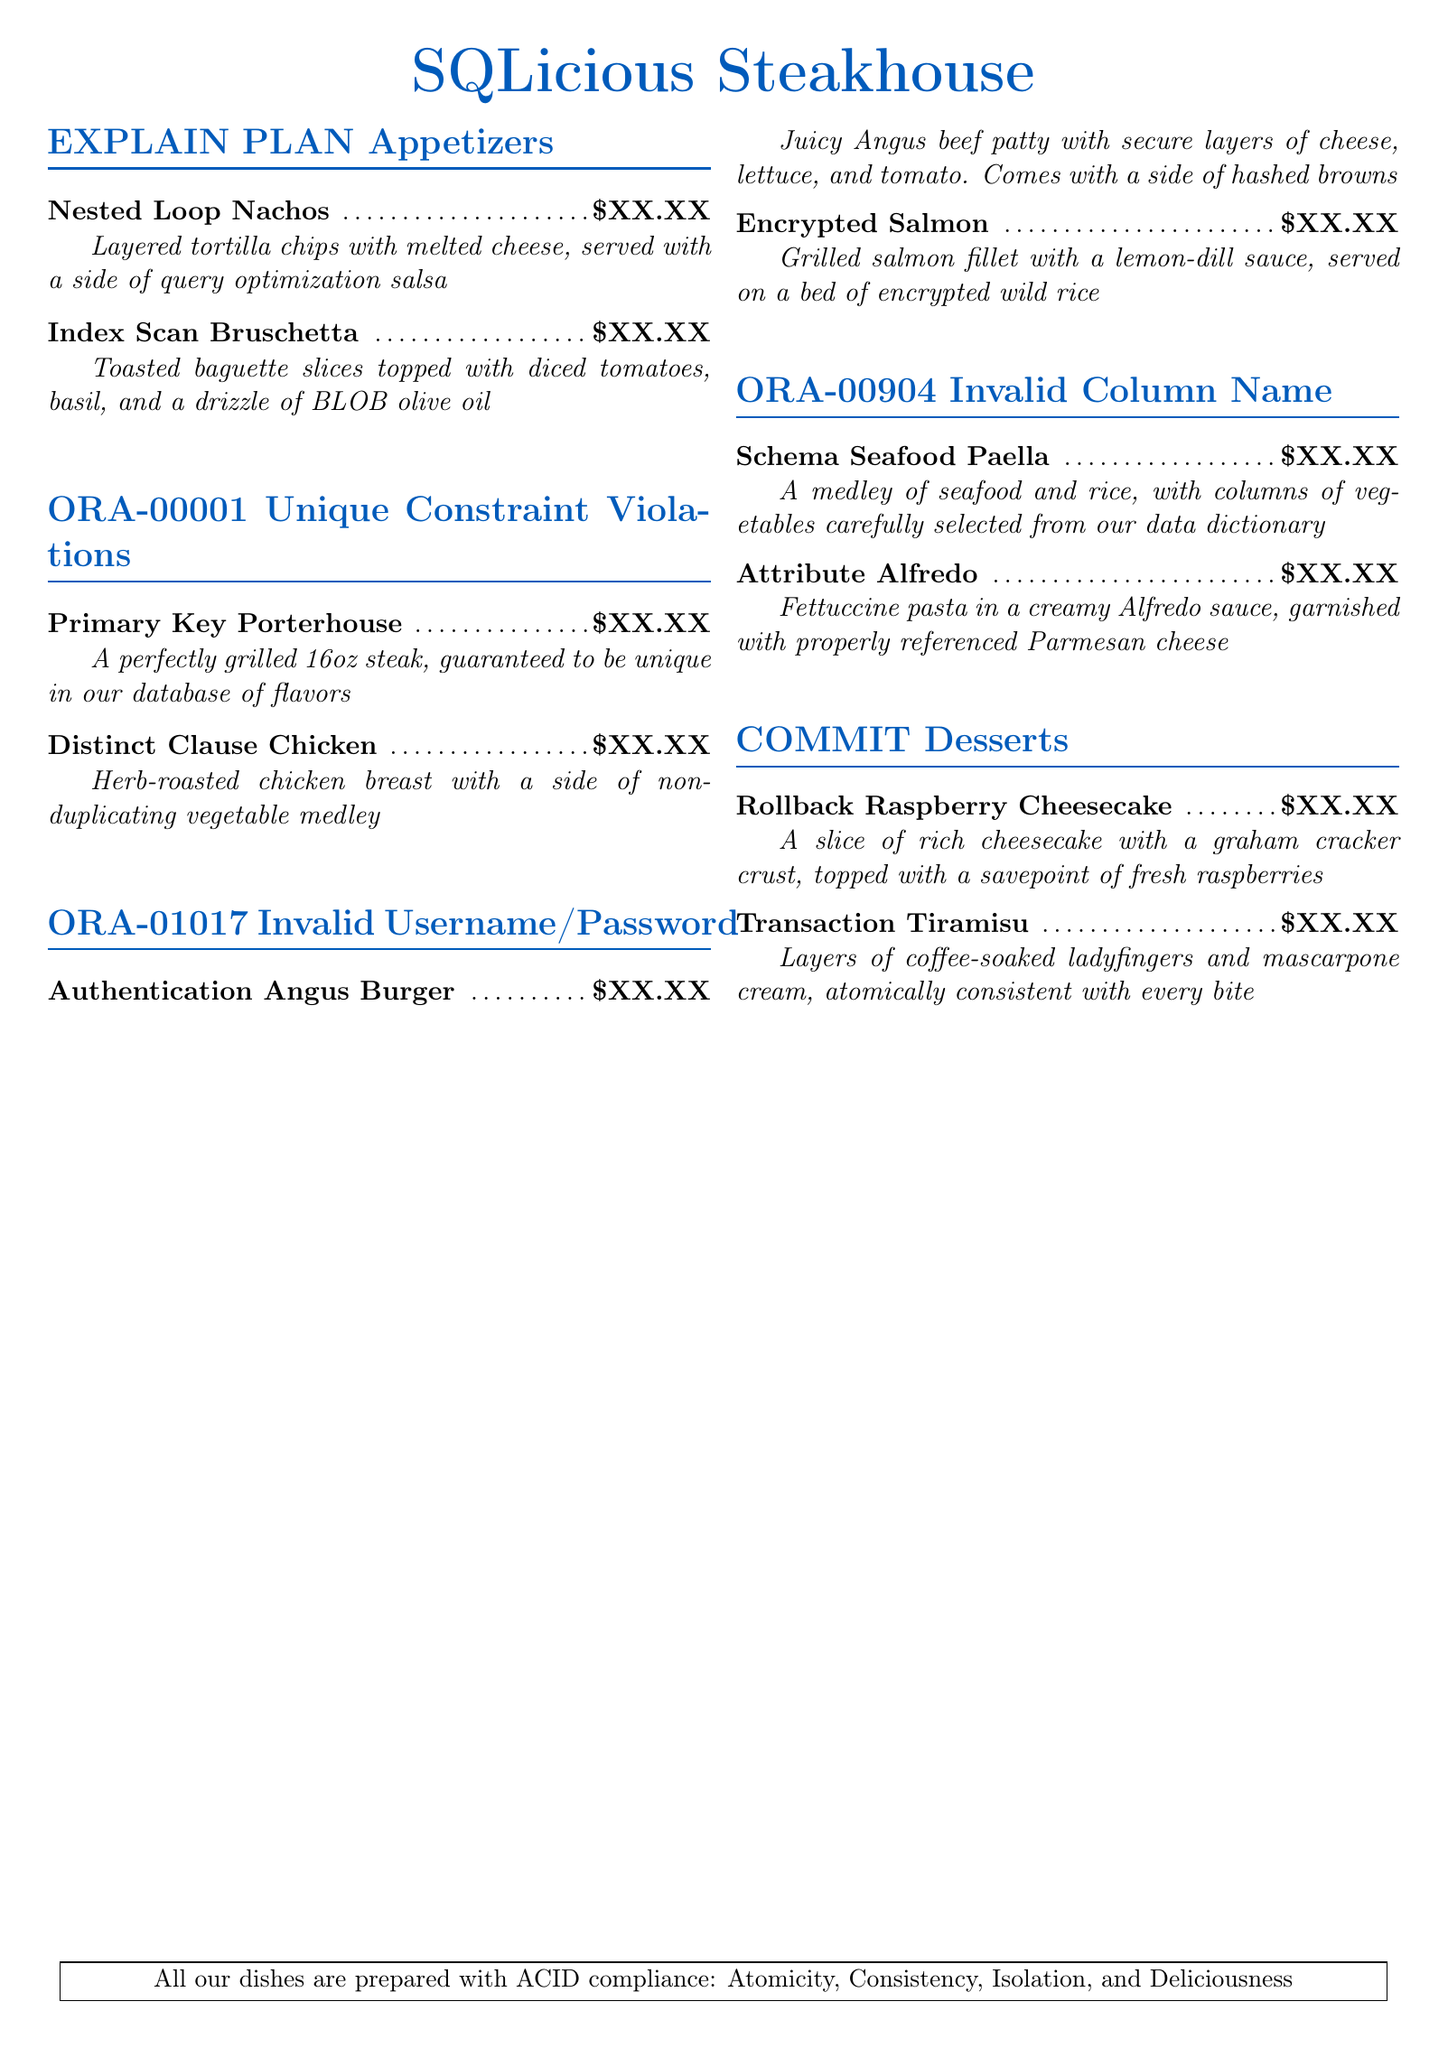What is the name of the steak featured in the unique constraint violation section? The document includes a dish named "Primary Key Porterhouse" under the unique constraint violation section.
Answer: Primary Key Porterhouse What price is listed for the Nested Loop Nachos? The price is indicated as $XX.XX next to the menu item "Nested Loop Nachos."
Answer: $XX.XX What type of fish is featured in the invalid username/password section? The dish "Encrypted Salmon" is mentioned as a seafood option in this section, indicating the type of fish.
Answer: Salmon Which dessert includes a layer of ladyfingers? The dessert "Transaction Tiramisu" includes layers of coffee-soaked ladyfingers as described in the menu.
Answer: Transaction Tiramisu What is unique about the "Primary Key Porterhouse"? The description states it is a perfectly grilled steak that is guaranteed to be unique in the database of flavors.
Answer: Unique in our database of flavors How many appetizer options are listed? The document lists two appetizers in the "EXPLAIN PLAN" section, counting them provides a clear answer.
Answer: 2 What sauce accompanies the Encrypted Salmon? The menu describes the sauce served with Encrypted Salmon as a lemon-dill sauce.
Answer: Lemon-dill What fruit is on top of the Rollback Raspberry Cheesecake? The dish is topped with fresh raspberries, which is specified in the description.
Answer: Raspberries 